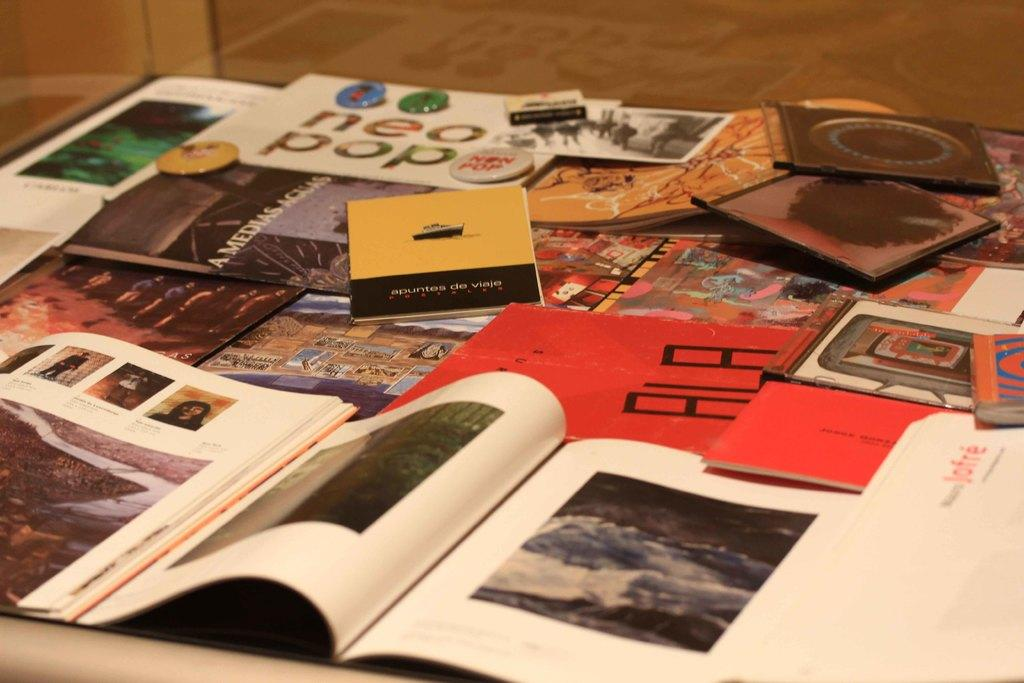What type of items can be seen in the image? There are books in the image. Can you describe the other objects on a surface in the image? Unfortunately, the provided facts do not specify the nature of the other objects on the surface. What type of lace is used to decorate the books in the image? There is no mention of lace in the provided facts, and therefore it cannot be determined if lace is present or used to decorate the books in the image. 